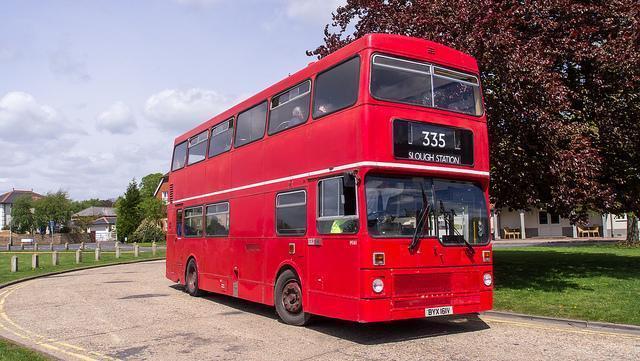How many decks is the bus?
Give a very brief answer. 2. How many cars are in front of the trolley?
Give a very brief answer. 0. How many chairs are at the table?
Give a very brief answer. 0. 